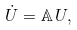Convert formula to latex. <formula><loc_0><loc_0><loc_500><loc_500>\dot { U } = \mathbb { A } \, U ,</formula> 